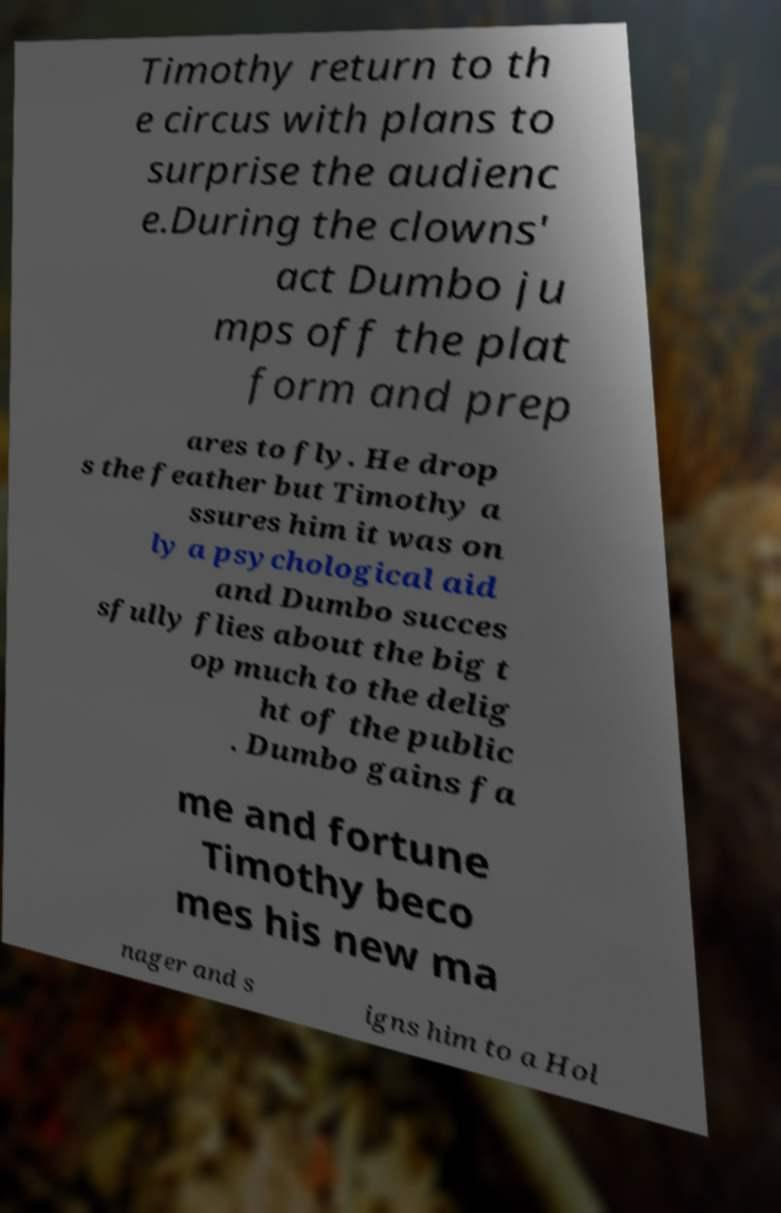Could you extract and type out the text from this image? Timothy return to th e circus with plans to surprise the audienc e.During the clowns' act Dumbo ju mps off the plat form and prep ares to fly. He drop s the feather but Timothy a ssures him it was on ly a psychological aid and Dumbo succes sfully flies about the big t op much to the delig ht of the public . Dumbo gains fa me and fortune Timothy beco mes his new ma nager and s igns him to a Hol 